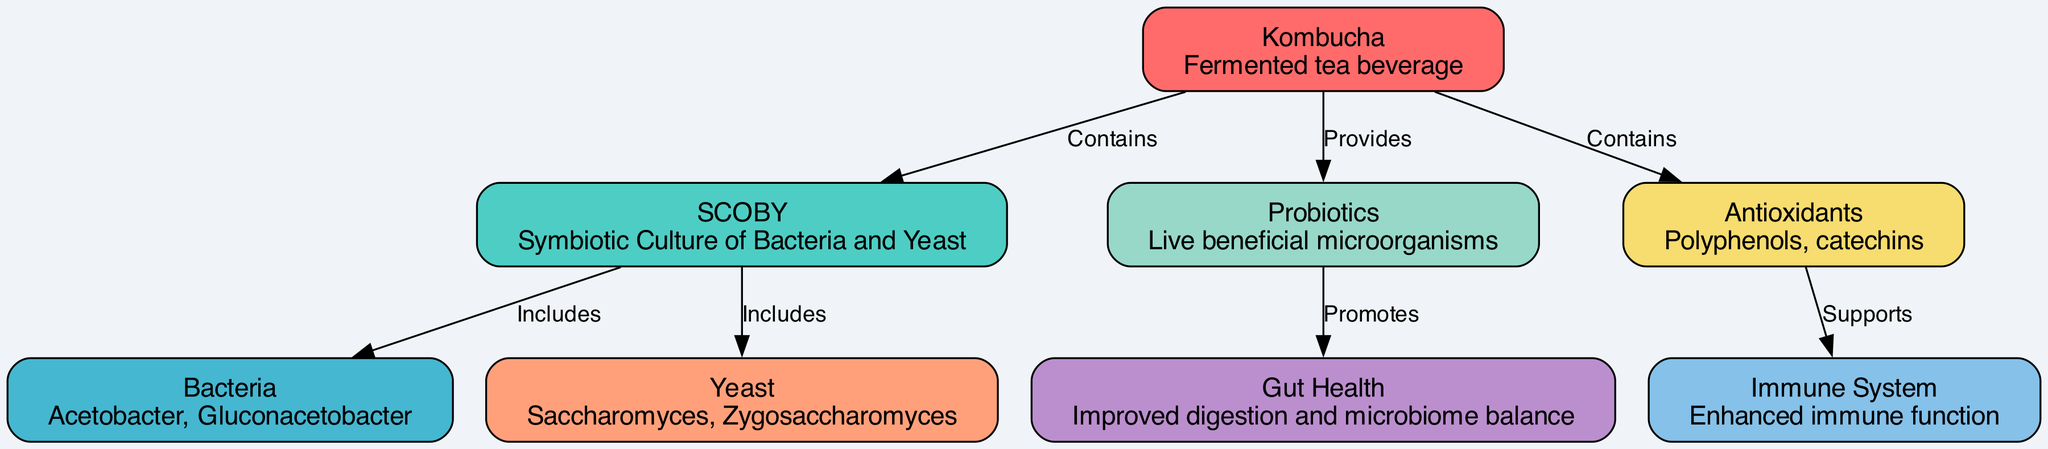What is the main beverage illustrated in the diagram? The diagram highlights "Kombucha" as the central beverage, described as a "Fermented tea beverage." It is the primary node in the visual representation.
Answer: Kombucha What kind of culture is included in kombucha? According to the diagram, "SCOBY" stands as a key component, which stands for "Symbiotic Culture of Bacteria and Yeast," conveying its significance in kombucha production.
Answer: SCOBY How many types of microorganisms are explicitly mentioned in the diagram? The diagram details two types, "Bacteria" and "Yeast," each with its own subsets specified: Acetobacter and Gluconacetobacter for bacteria, and Saccharomyces and Zygosaccharomyces for yeast, leading to a total of two categories.
Answer: 2 What does kombucha provide that promotes gut health? The "probiotics" node, which connects back to kombucha, is specifically labeled as "Provides" from kombucha. Probiotics are recognized for their role in improving gut health.
Answer: Probiotics What supports the immune system according to the diagram? The "antioxidants" node is connected to the "immune system," indicating that antioxidants, which include polyphenols and catechins, have a supportive effect on immune function.
Answer: Antioxidants Which group of microorganisms includes bacteria? The "SCOBY" node is detailed as including both "Bacteria" and "Yeast." Specifically, the relationship highlights that bacteria are part of the symbiotic culture in kombucha.
Answer: Bacteria What health benefit is promoted by probiotics? The diagram illustrates that "probiotics" promote "gut health," establishing that they contribute positively to digestion and microbiome balance.
Answer: Gut Health What are the two types of yeast mentioned in the diagram? "Saccharomyces" and "Zygosaccharomyces" are the two specific types of yeast identified in the diagram under the yeast category in the "SCOBY."
Answer: Saccharomyces, Zygosaccharomyces How does antioxidants affect the immune system? The diagram indicates that "antioxidants" support the immune system, suggesting a direct relationship between the presence of antioxidants and immune function enhancement.
Answer: Supports 